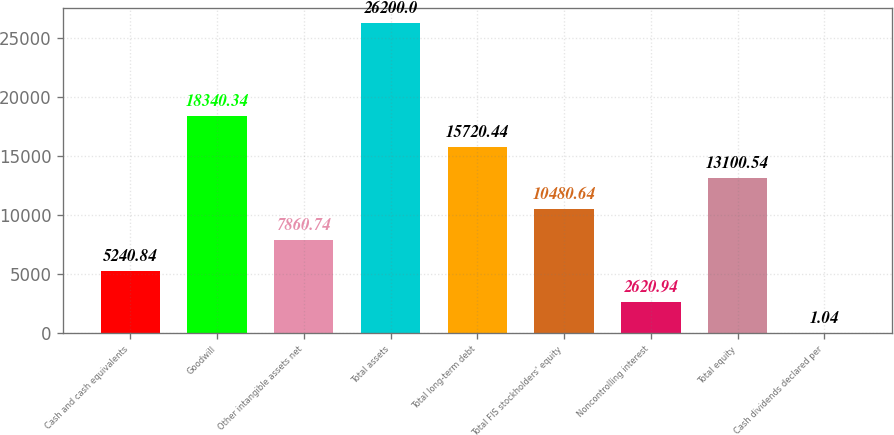Convert chart to OTSL. <chart><loc_0><loc_0><loc_500><loc_500><bar_chart><fcel>Cash and cash equivalents<fcel>Goodwill<fcel>Other intangible assets net<fcel>Total assets<fcel>Total long-term debt<fcel>Total FIS stockholders' equity<fcel>Noncontrolling interest<fcel>Total equity<fcel>Cash dividends declared per<nl><fcel>5240.84<fcel>18340.3<fcel>7860.74<fcel>26200<fcel>15720.4<fcel>10480.6<fcel>2620.94<fcel>13100.5<fcel>1.04<nl></chart> 